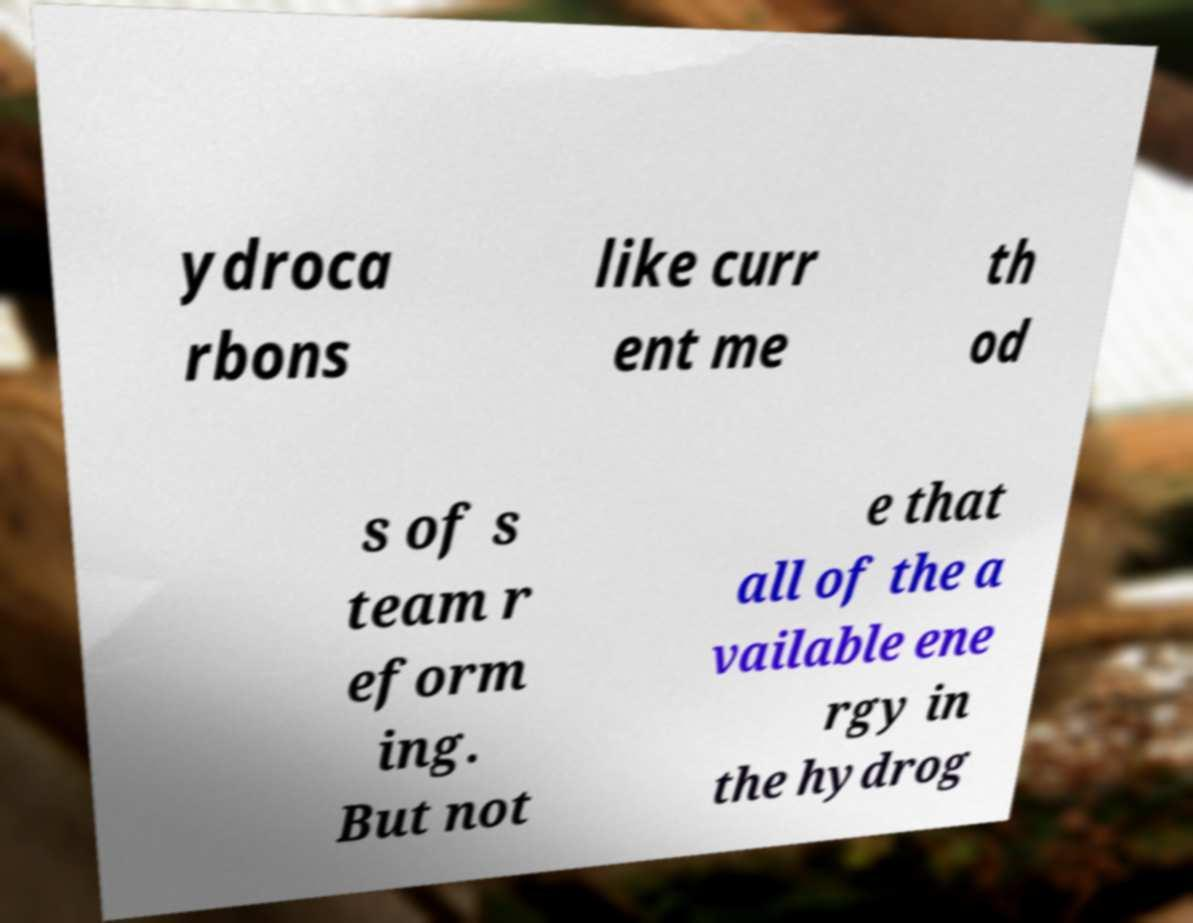There's text embedded in this image that I need extracted. Can you transcribe it verbatim? ydroca rbons like curr ent me th od s of s team r eform ing. But not e that all of the a vailable ene rgy in the hydrog 